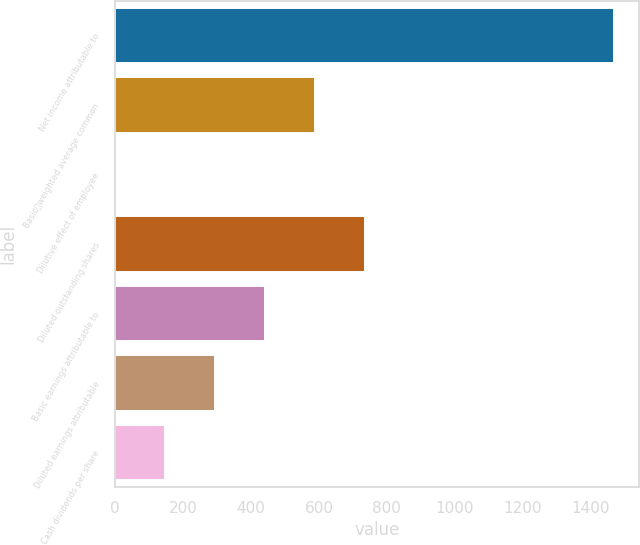Convert chart. <chart><loc_0><loc_0><loc_500><loc_500><bar_chart><fcel>Net income attributable to<fcel>Basicweighted average common<fcel>Dilutive effect of employee<fcel>Diluted outstanding shares<fcel>Basic earnings attributable to<fcel>Diluted earnings attributable<fcel>Cash dividends per share<nl><fcel>1469<fcel>588.2<fcel>1<fcel>735<fcel>441.4<fcel>294.6<fcel>147.8<nl></chart> 